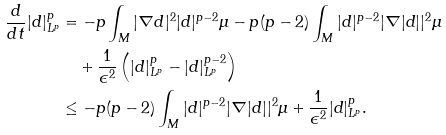Convert formula to latex. <formula><loc_0><loc_0><loc_500><loc_500>\frac { d } { d t } | d | _ { L ^ { p } } ^ { p } & = - p \int _ { M } | \nabla d | ^ { 2 } | d | ^ { p - 2 } \mu - p ( p - 2 ) \int _ { M } | d | ^ { p - 2 } | \nabla | d | | ^ { 2 } \mu \\ & \quad + { \frac { 1 } { \epsilon ^ { 2 } } } \left ( | d | _ { L ^ { p } } ^ { p } - | d | _ { L ^ { p } } ^ { p - 2 } \right ) \\ & \leq - p ( p - 2 ) \int _ { M } | d | ^ { p - 2 } | \nabla | d | | ^ { 2 } \mu + \frac { 1 } { \epsilon ^ { 2 } } | d | _ { L ^ { p } } ^ { p } .</formula> 